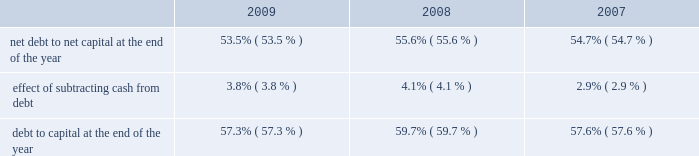Entergy corporation and subsidiaries management's financial discussion and analysis methodology of computing massachusetts state income taxes resulting from legislation passed in the third quarter 2008 , which resulted in an income tax benefit of approximately $ 18.8 million .
These factors were partially offset by : income taxes recorded by entergy power generation , llc , prior to its liquidation , resulting from the redemption payments it received in connection with its investment in entergy nuclear power marketing , llc during the third quarter 2008 , which resulted in an income tax expense of approximately $ 16.1 million ; book and tax differences for utility plant items and state income taxes at the utility operating companies , including the flow-through treatment of the entergy arkansas write-offs discussed above .
The effective income tax rate for 2007 was 30.7% ( 30.7 % ) .
The reduction in the effective income tax rate versus the federal statutory rate of 35% ( 35 % ) in 2007 is primarily due to : a reduction in income tax expense due to a step-up in the tax basis on the indian point 2 non-qualified decommissioning trust fund resulting from restructuring of the trusts , which reduced deferred taxes on the trust fund and reduced current tax expense ; the resolution of tax audit issues involving the 2002-2003 audit cycle ; an adjustment to state income taxes for non-utility nuclear to reflect the effect of a change in the methodology of computing new york state income taxes as required by that state's taxing authority ; book and tax differences related to the allowance for equity funds used during construction ; and the amortization of investment tax credits .
These factors were partially offset by book and tax differences for utility plant items and state income taxes at the utility operating companies .
See note 3 to the financial statements for a reconciliation of the federal statutory rate of 35.0% ( 35.0 % ) to the effective income tax rates , and for additional discussion regarding income taxes .
Liquidity and capital resources this section discusses entergy's capital structure , capital spending plans and other uses of capital , sources of capital , and the cash flow activity presented in the cash flow statement .
Capital structure entergy's capitalization is balanced between equity and debt , as shown in the table .
The decrease in the debt to capital percentage from 2008 to 2009 is primarily the result of an increase in shareholders' equity primarily due to an increase in retained earnings , partially offset by repurchases of common stock , along with a decrease in borrowings under entergy corporation's revolving credit facility .
The increase in the debt to capital percentage from 2007 to 2008 is primarily the result of additional borrowings under entergy corporation's revolving credit facility. .

What is the growth rate of net debt to net capital ratio from 2008 to 2009? 
Computations: ((53.5 - 55.6) / 55.6)
Answer: -0.03777. 